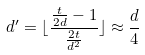<formula> <loc_0><loc_0><loc_500><loc_500>d ^ { \prime } = \lfloor \frac { \frac { t } { 2 d } - 1 } { \frac { 2 t } { d ^ { 2 } } } \rfloor \approx \frac { d } { 4 }</formula> 